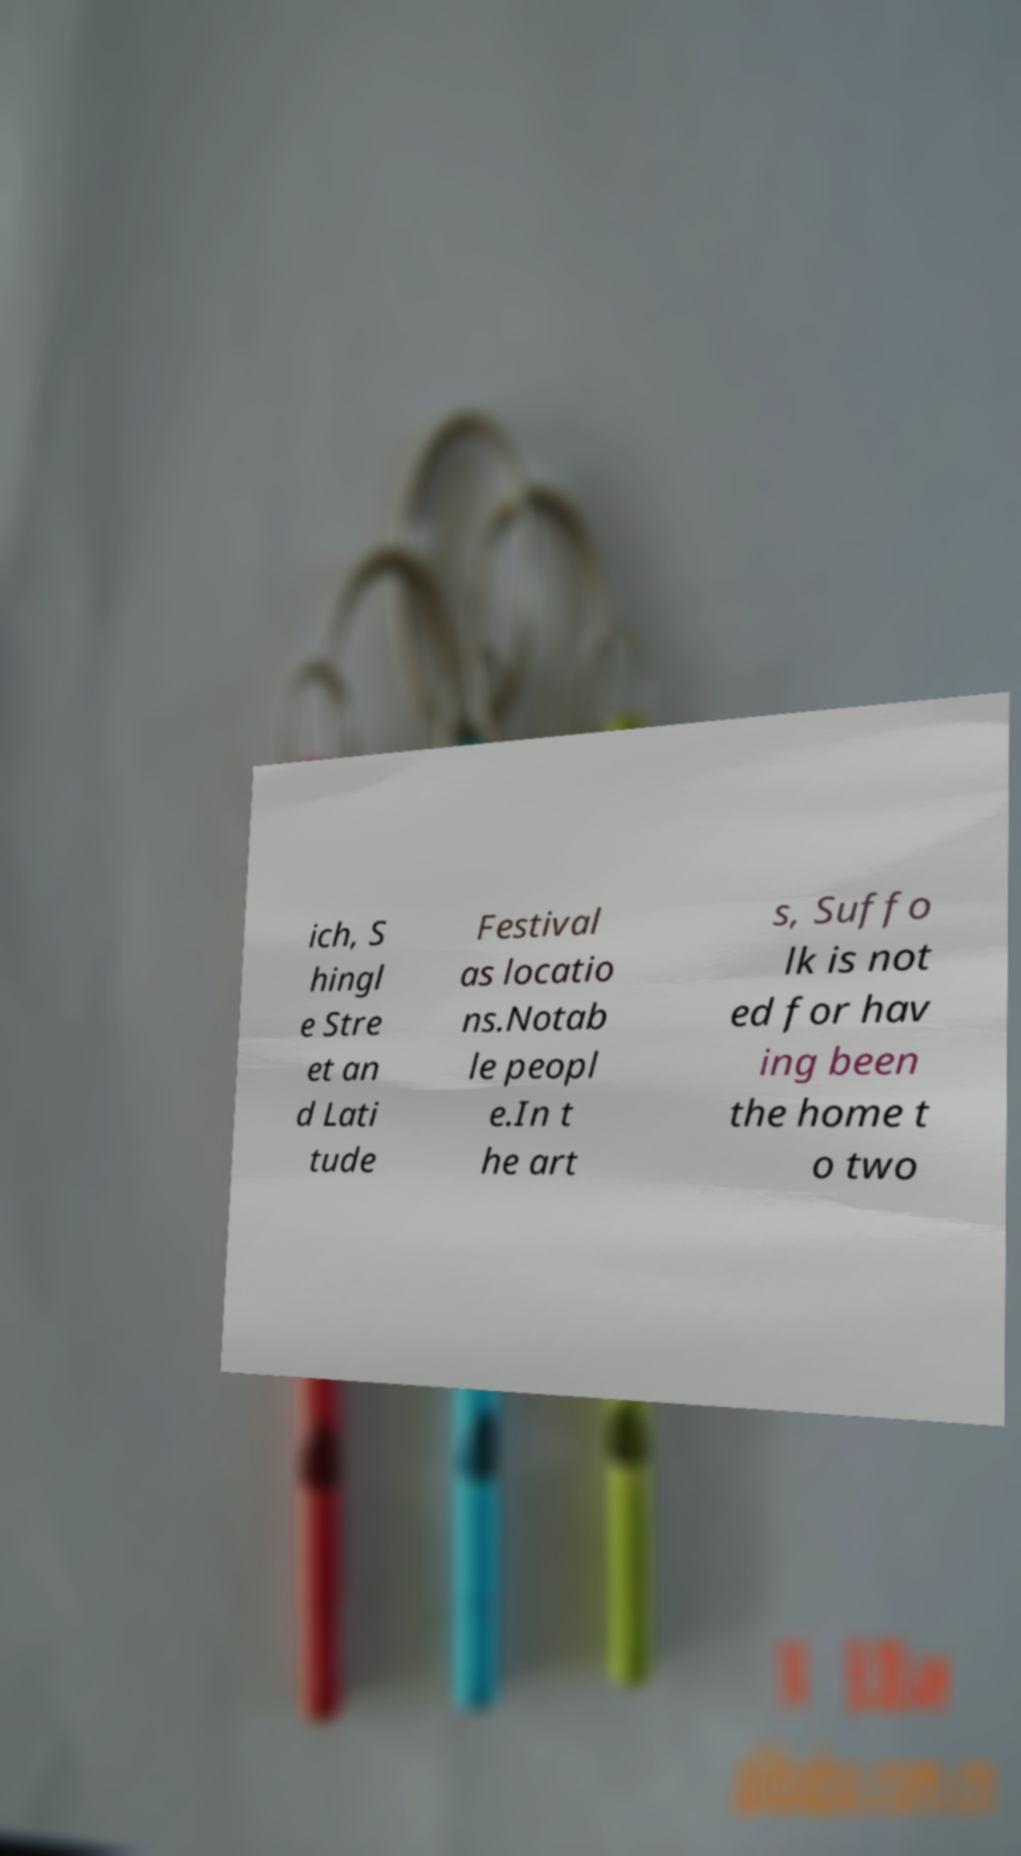What messages or text are displayed in this image? I need them in a readable, typed format. ich, S hingl e Stre et an d Lati tude Festival as locatio ns.Notab le peopl e.In t he art s, Suffo lk is not ed for hav ing been the home t o two 